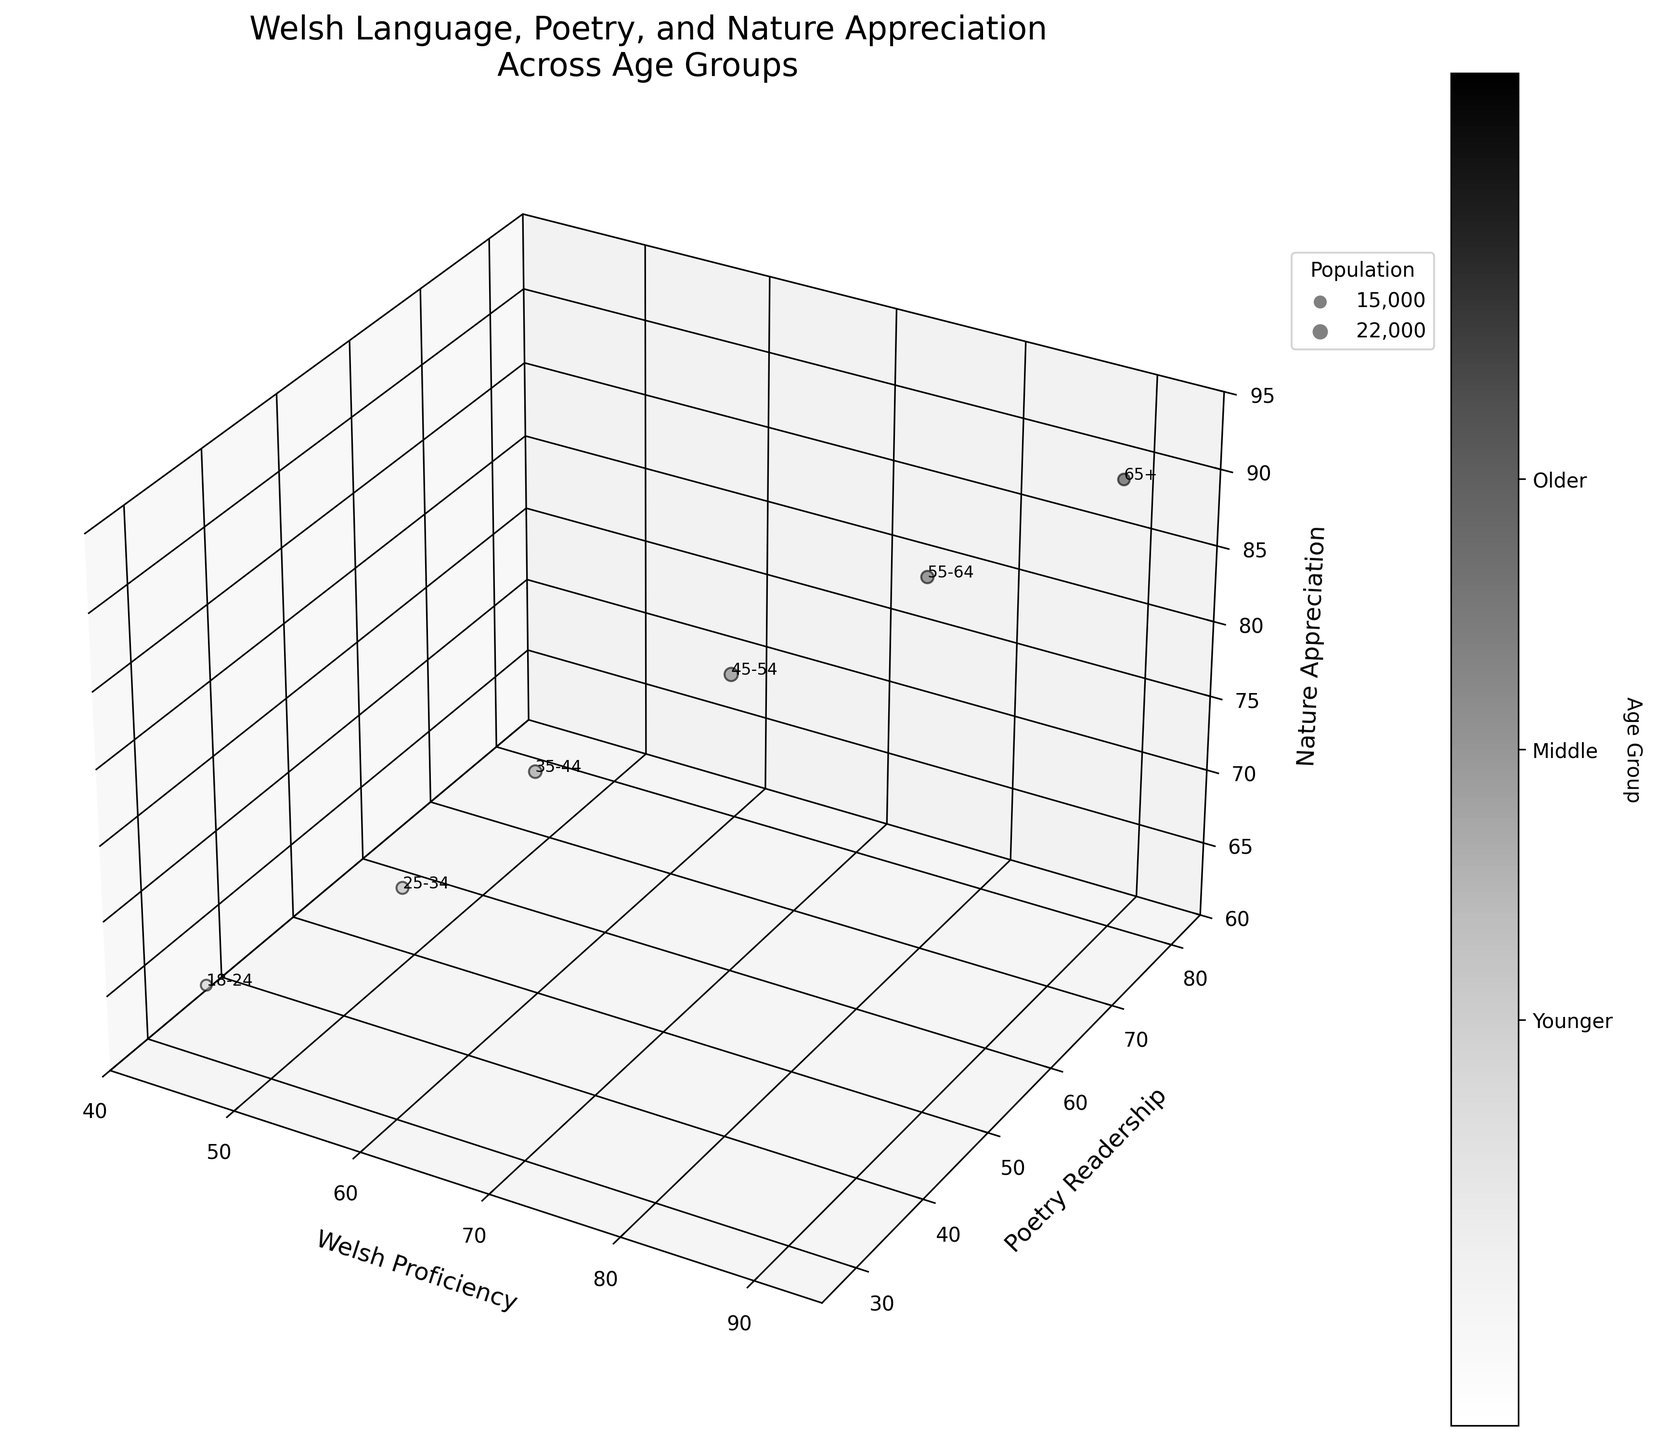What's the title of the chart? The title of the chart is at the top and is labeled "Welsh Language, Poetry, and Nature Appreciation Across Age Groups."
Answer: Welsh Language, Poetry, and Nature Appreciation Across Age Groups What are the axes labels in the 3D bubble chart? The x-axis is labeled "Welsh Proficiency," the y-axis is labeled "Poetry Readership," and the z-axis is labeled "Nature Appreciation."
Answer: Welsh Proficiency, Poetry Readership, Nature Appreciation Which age group has the highest Welsh Proficiency? The age group with the highest Welsh Proficiency is located at the point with the highest x-value on the chart. The highest x-value is 90.
Answer: 65+ How does the Poetry Readership change as we move from the 18-24 age group to the 65+ age group? As we move from the 18-24 age group to the 65+ age group, we follow the y-axis values of the bubbles. The y-values start at 30 and end at 80, indicating an increase in Poetry Readership.
Answer: It increases Which age group has the smallest bubble size? The bubble size represents the population size. The smallest bubble corresponds to the smallest population value. The smallest population is 15,000.
Answer: 18-24 What is the relationship between Nature Appreciation and Welsh Proficiency for the 25-34 age group? For the 25-34 age group, check the Nature Appreciation value on the z-axis and the Welsh Proficiency value on the x-axis. The values are 70 and 55, respectively.
Answer: Nature Appreciation is higher than Welsh Proficiency Compare the Welsh Proficiency of the 45-54 and 55-64 age groups. The Welsh Proficiency for the 45-54 age group is 70, and for the 55-64 age group, it is 80. Compare these values to determine which is higher.
Answer: 55-64 is higher Which age groups have a Nature Appreciation value of 85 or higher? Check which bubbles have a z-axis value of 85 or higher. The values 85 and 90 are located for the 55-64 and 65+ age groups, respectively.
Answer: 55-64 and 65+ What is the general trend of the bubble sizes from left to right on the x-axis? The x-axis represents Welsh Proficiency. Generally, as you move from left (lower Welsh Proficiency) to right (higher Welsh Proficiency), the bubble sizes increase indicating larger populations.
Answer: Increasing 